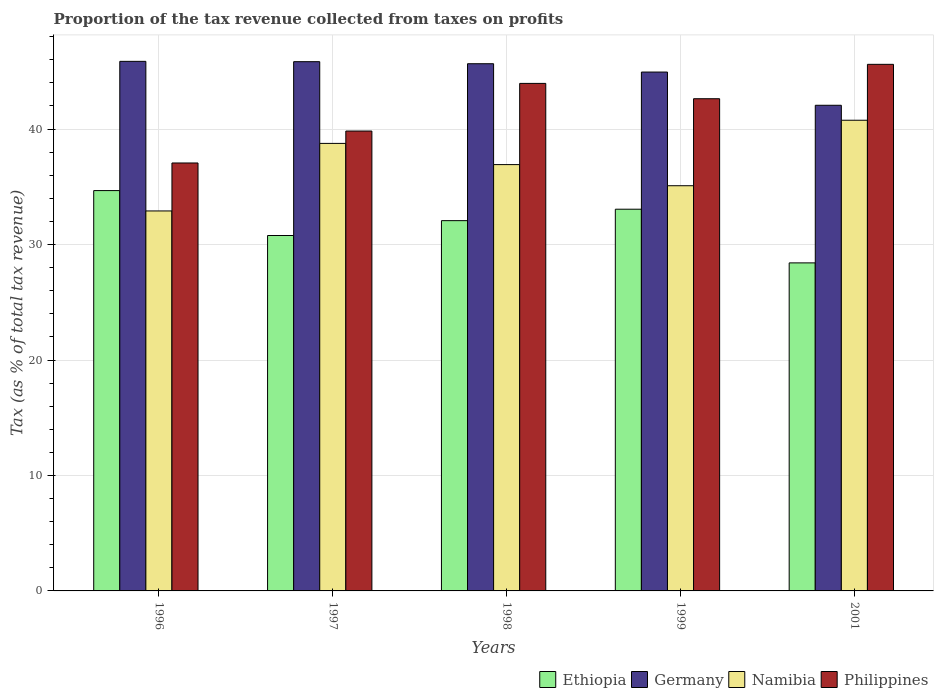How many different coloured bars are there?
Ensure brevity in your answer.  4. How many groups of bars are there?
Provide a succinct answer. 5. How many bars are there on the 4th tick from the left?
Provide a succinct answer. 4. How many bars are there on the 4th tick from the right?
Provide a succinct answer. 4. In how many cases, is the number of bars for a given year not equal to the number of legend labels?
Offer a terse response. 0. What is the proportion of the tax revenue collected in Namibia in 2001?
Keep it short and to the point. 40.77. Across all years, what is the maximum proportion of the tax revenue collected in Namibia?
Keep it short and to the point. 40.77. Across all years, what is the minimum proportion of the tax revenue collected in Ethiopia?
Provide a short and direct response. 28.41. What is the total proportion of the tax revenue collected in Ethiopia in the graph?
Provide a short and direct response. 159. What is the difference between the proportion of the tax revenue collected in Philippines in 1996 and that in 2001?
Make the answer very short. -8.54. What is the difference between the proportion of the tax revenue collected in Philippines in 1999 and the proportion of the tax revenue collected in Germany in 1996?
Give a very brief answer. -3.24. What is the average proportion of the tax revenue collected in Ethiopia per year?
Provide a short and direct response. 31.8. In the year 1998, what is the difference between the proportion of the tax revenue collected in Ethiopia and proportion of the tax revenue collected in Namibia?
Your answer should be very brief. -4.85. What is the ratio of the proportion of the tax revenue collected in Ethiopia in 1997 to that in 1998?
Keep it short and to the point. 0.96. Is the proportion of the tax revenue collected in Ethiopia in 1996 less than that in 1997?
Provide a short and direct response. No. Is the difference between the proportion of the tax revenue collected in Ethiopia in 1997 and 2001 greater than the difference between the proportion of the tax revenue collected in Namibia in 1997 and 2001?
Your answer should be compact. Yes. What is the difference between the highest and the second highest proportion of the tax revenue collected in Ethiopia?
Ensure brevity in your answer.  1.61. What is the difference between the highest and the lowest proportion of the tax revenue collected in Philippines?
Your answer should be very brief. 8.54. What does the 1st bar from the left in 1999 represents?
Ensure brevity in your answer.  Ethiopia. How many bars are there?
Provide a short and direct response. 20. How many years are there in the graph?
Provide a short and direct response. 5. What is the difference between two consecutive major ticks on the Y-axis?
Provide a succinct answer. 10. Where does the legend appear in the graph?
Make the answer very short. Bottom right. How many legend labels are there?
Offer a very short reply. 4. What is the title of the graph?
Keep it short and to the point. Proportion of the tax revenue collected from taxes on profits. What is the label or title of the X-axis?
Your answer should be compact. Years. What is the label or title of the Y-axis?
Ensure brevity in your answer.  Tax (as % of total tax revenue). What is the Tax (as % of total tax revenue) in Ethiopia in 1996?
Your response must be concise. 34.67. What is the Tax (as % of total tax revenue) of Germany in 1996?
Provide a short and direct response. 45.87. What is the Tax (as % of total tax revenue) in Namibia in 1996?
Offer a terse response. 32.91. What is the Tax (as % of total tax revenue) in Philippines in 1996?
Keep it short and to the point. 37.06. What is the Tax (as % of total tax revenue) in Ethiopia in 1997?
Provide a succinct answer. 30.78. What is the Tax (as % of total tax revenue) of Germany in 1997?
Provide a succinct answer. 45.84. What is the Tax (as % of total tax revenue) in Namibia in 1997?
Provide a succinct answer. 38.76. What is the Tax (as % of total tax revenue) of Philippines in 1997?
Your answer should be very brief. 39.83. What is the Tax (as % of total tax revenue) in Ethiopia in 1998?
Give a very brief answer. 32.07. What is the Tax (as % of total tax revenue) in Germany in 1998?
Provide a short and direct response. 45.66. What is the Tax (as % of total tax revenue) in Namibia in 1998?
Ensure brevity in your answer.  36.92. What is the Tax (as % of total tax revenue) of Philippines in 1998?
Give a very brief answer. 43.96. What is the Tax (as % of total tax revenue) in Ethiopia in 1999?
Keep it short and to the point. 33.06. What is the Tax (as % of total tax revenue) of Germany in 1999?
Your answer should be compact. 44.94. What is the Tax (as % of total tax revenue) of Namibia in 1999?
Give a very brief answer. 35.09. What is the Tax (as % of total tax revenue) in Philippines in 1999?
Offer a terse response. 42.63. What is the Tax (as % of total tax revenue) in Ethiopia in 2001?
Keep it short and to the point. 28.41. What is the Tax (as % of total tax revenue) in Germany in 2001?
Provide a succinct answer. 42.06. What is the Tax (as % of total tax revenue) of Namibia in 2001?
Your answer should be compact. 40.77. What is the Tax (as % of total tax revenue) in Philippines in 2001?
Offer a very short reply. 45.61. Across all years, what is the maximum Tax (as % of total tax revenue) of Ethiopia?
Provide a short and direct response. 34.67. Across all years, what is the maximum Tax (as % of total tax revenue) in Germany?
Provide a succinct answer. 45.87. Across all years, what is the maximum Tax (as % of total tax revenue) of Namibia?
Provide a succinct answer. 40.77. Across all years, what is the maximum Tax (as % of total tax revenue) of Philippines?
Your answer should be compact. 45.61. Across all years, what is the minimum Tax (as % of total tax revenue) in Ethiopia?
Offer a very short reply. 28.41. Across all years, what is the minimum Tax (as % of total tax revenue) of Germany?
Ensure brevity in your answer.  42.06. Across all years, what is the minimum Tax (as % of total tax revenue) of Namibia?
Make the answer very short. 32.91. Across all years, what is the minimum Tax (as % of total tax revenue) of Philippines?
Give a very brief answer. 37.06. What is the total Tax (as % of total tax revenue) of Ethiopia in the graph?
Make the answer very short. 159. What is the total Tax (as % of total tax revenue) of Germany in the graph?
Offer a terse response. 224.36. What is the total Tax (as % of total tax revenue) of Namibia in the graph?
Your answer should be compact. 184.45. What is the total Tax (as % of total tax revenue) in Philippines in the graph?
Keep it short and to the point. 209.09. What is the difference between the Tax (as % of total tax revenue) in Ethiopia in 1996 and that in 1997?
Give a very brief answer. 3.89. What is the difference between the Tax (as % of total tax revenue) of Germany in 1996 and that in 1997?
Provide a succinct answer. 0.03. What is the difference between the Tax (as % of total tax revenue) of Namibia in 1996 and that in 1997?
Offer a very short reply. -5.85. What is the difference between the Tax (as % of total tax revenue) of Philippines in 1996 and that in 1997?
Offer a terse response. -2.77. What is the difference between the Tax (as % of total tax revenue) in Ethiopia in 1996 and that in 1998?
Provide a short and direct response. 2.6. What is the difference between the Tax (as % of total tax revenue) of Germany in 1996 and that in 1998?
Your answer should be compact. 0.21. What is the difference between the Tax (as % of total tax revenue) of Namibia in 1996 and that in 1998?
Make the answer very short. -4.01. What is the difference between the Tax (as % of total tax revenue) in Philippines in 1996 and that in 1998?
Your answer should be compact. -6.89. What is the difference between the Tax (as % of total tax revenue) in Ethiopia in 1996 and that in 1999?
Make the answer very short. 1.61. What is the difference between the Tax (as % of total tax revenue) of Germany in 1996 and that in 1999?
Provide a short and direct response. 0.93. What is the difference between the Tax (as % of total tax revenue) of Namibia in 1996 and that in 1999?
Your answer should be very brief. -2.18. What is the difference between the Tax (as % of total tax revenue) in Philippines in 1996 and that in 1999?
Offer a terse response. -5.57. What is the difference between the Tax (as % of total tax revenue) in Ethiopia in 1996 and that in 2001?
Keep it short and to the point. 6.26. What is the difference between the Tax (as % of total tax revenue) in Germany in 1996 and that in 2001?
Ensure brevity in your answer.  3.8. What is the difference between the Tax (as % of total tax revenue) of Namibia in 1996 and that in 2001?
Make the answer very short. -7.86. What is the difference between the Tax (as % of total tax revenue) in Philippines in 1996 and that in 2001?
Keep it short and to the point. -8.54. What is the difference between the Tax (as % of total tax revenue) of Ethiopia in 1997 and that in 1998?
Offer a terse response. -1.29. What is the difference between the Tax (as % of total tax revenue) of Germany in 1997 and that in 1998?
Offer a very short reply. 0.18. What is the difference between the Tax (as % of total tax revenue) of Namibia in 1997 and that in 1998?
Offer a terse response. 1.84. What is the difference between the Tax (as % of total tax revenue) of Philippines in 1997 and that in 1998?
Ensure brevity in your answer.  -4.13. What is the difference between the Tax (as % of total tax revenue) in Ethiopia in 1997 and that in 1999?
Offer a very short reply. -2.28. What is the difference between the Tax (as % of total tax revenue) in Germany in 1997 and that in 1999?
Ensure brevity in your answer.  0.9. What is the difference between the Tax (as % of total tax revenue) of Namibia in 1997 and that in 1999?
Give a very brief answer. 3.67. What is the difference between the Tax (as % of total tax revenue) in Philippines in 1997 and that in 1999?
Offer a terse response. -2.8. What is the difference between the Tax (as % of total tax revenue) in Ethiopia in 1997 and that in 2001?
Offer a terse response. 2.37. What is the difference between the Tax (as % of total tax revenue) in Germany in 1997 and that in 2001?
Your answer should be compact. 3.78. What is the difference between the Tax (as % of total tax revenue) of Namibia in 1997 and that in 2001?
Give a very brief answer. -2.01. What is the difference between the Tax (as % of total tax revenue) of Philippines in 1997 and that in 2001?
Your response must be concise. -5.78. What is the difference between the Tax (as % of total tax revenue) in Ethiopia in 1998 and that in 1999?
Keep it short and to the point. -0.99. What is the difference between the Tax (as % of total tax revenue) in Germany in 1998 and that in 1999?
Provide a short and direct response. 0.72. What is the difference between the Tax (as % of total tax revenue) in Namibia in 1998 and that in 1999?
Offer a terse response. 1.83. What is the difference between the Tax (as % of total tax revenue) in Philippines in 1998 and that in 1999?
Make the answer very short. 1.33. What is the difference between the Tax (as % of total tax revenue) of Ethiopia in 1998 and that in 2001?
Keep it short and to the point. 3.66. What is the difference between the Tax (as % of total tax revenue) of Germany in 1998 and that in 2001?
Ensure brevity in your answer.  3.6. What is the difference between the Tax (as % of total tax revenue) in Namibia in 1998 and that in 2001?
Give a very brief answer. -3.84. What is the difference between the Tax (as % of total tax revenue) in Philippines in 1998 and that in 2001?
Offer a very short reply. -1.65. What is the difference between the Tax (as % of total tax revenue) in Ethiopia in 1999 and that in 2001?
Your answer should be compact. 4.65. What is the difference between the Tax (as % of total tax revenue) of Germany in 1999 and that in 2001?
Make the answer very short. 2.88. What is the difference between the Tax (as % of total tax revenue) of Namibia in 1999 and that in 2001?
Ensure brevity in your answer.  -5.67. What is the difference between the Tax (as % of total tax revenue) of Philippines in 1999 and that in 2001?
Offer a terse response. -2.98. What is the difference between the Tax (as % of total tax revenue) in Ethiopia in 1996 and the Tax (as % of total tax revenue) in Germany in 1997?
Provide a short and direct response. -11.16. What is the difference between the Tax (as % of total tax revenue) in Ethiopia in 1996 and the Tax (as % of total tax revenue) in Namibia in 1997?
Your answer should be very brief. -4.09. What is the difference between the Tax (as % of total tax revenue) in Ethiopia in 1996 and the Tax (as % of total tax revenue) in Philippines in 1997?
Offer a terse response. -5.16. What is the difference between the Tax (as % of total tax revenue) of Germany in 1996 and the Tax (as % of total tax revenue) of Namibia in 1997?
Provide a short and direct response. 7.11. What is the difference between the Tax (as % of total tax revenue) of Germany in 1996 and the Tax (as % of total tax revenue) of Philippines in 1997?
Ensure brevity in your answer.  6.04. What is the difference between the Tax (as % of total tax revenue) in Namibia in 1996 and the Tax (as % of total tax revenue) in Philippines in 1997?
Ensure brevity in your answer.  -6.92. What is the difference between the Tax (as % of total tax revenue) in Ethiopia in 1996 and the Tax (as % of total tax revenue) in Germany in 1998?
Provide a short and direct response. -10.99. What is the difference between the Tax (as % of total tax revenue) in Ethiopia in 1996 and the Tax (as % of total tax revenue) in Namibia in 1998?
Ensure brevity in your answer.  -2.25. What is the difference between the Tax (as % of total tax revenue) in Ethiopia in 1996 and the Tax (as % of total tax revenue) in Philippines in 1998?
Ensure brevity in your answer.  -9.28. What is the difference between the Tax (as % of total tax revenue) of Germany in 1996 and the Tax (as % of total tax revenue) of Namibia in 1998?
Offer a terse response. 8.94. What is the difference between the Tax (as % of total tax revenue) of Germany in 1996 and the Tax (as % of total tax revenue) of Philippines in 1998?
Keep it short and to the point. 1.91. What is the difference between the Tax (as % of total tax revenue) of Namibia in 1996 and the Tax (as % of total tax revenue) of Philippines in 1998?
Make the answer very short. -11.05. What is the difference between the Tax (as % of total tax revenue) in Ethiopia in 1996 and the Tax (as % of total tax revenue) in Germany in 1999?
Your answer should be very brief. -10.27. What is the difference between the Tax (as % of total tax revenue) of Ethiopia in 1996 and the Tax (as % of total tax revenue) of Namibia in 1999?
Your answer should be compact. -0.42. What is the difference between the Tax (as % of total tax revenue) in Ethiopia in 1996 and the Tax (as % of total tax revenue) in Philippines in 1999?
Offer a very short reply. -7.96. What is the difference between the Tax (as % of total tax revenue) of Germany in 1996 and the Tax (as % of total tax revenue) of Namibia in 1999?
Offer a very short reply. 10.77. What is the difference between the Tax (as % of total tax revenue) in Germany in 1996 and the Tax (as % of total tax revenue) in Philippines in 1999?
Ensure brevity in your answer.  3.24. What is the difference between the Tax (as % of total tax revenue) in Namibia in 1996 and the Tax (as % of total tax revenue) in Philippines in 1999?
Provide a short and direct response. -9.72. What is the difference between the Tax (as % of total tax revenue) in Ethiopia in 1996 and the Tax (as % of total tax revenue) in Germany in 2001?
Give a very brief answer. -7.39. What is the difference between the Tax (as % of total tax revenue) in Ethiopia in 1996 and the Tax (as % of total tax revenue) in Namibia in 2001?
Offer a terse response. -6.09. What is the difference between the Tax (as % of total tax revenue) of Ethiopia in 1996 and the Tax (as % of total tax revenue) of Philippines in 2001?
Offer a terse response. -10.93. What is the difference between the Tax (as % of total tax revenue) of Germany in 1996 and the Tax (as % of total tax revenue) of Namibia in 2001?
Offer a terse response. 5.1. What is the difference between the Tax (as % of total tax revenue) in Germany in 1996 and the Tax (as % of total tax revenue) in Philippines in 2001?
Ensure brevity in your answer.  0.26. What is the difference between the Tax (as % of total tax revenue) of Namibia in 1996 and the Tax (as % of total tax revenue) of Philippines in 2001?
Keep it short and to the point. -12.7. What is the difference between the Tax (as % of total tax revenue) in Ethiopia in 1997 and the Tax (as % of total tax revenue) in Germany in 1998?
Give a very brief answer. -14.88. What is the difference between the Tax (as % of total tax revenue) of Ethiopia in 1997 and the Tax (as % of total tax revenue) of Namibia in 1998?
Offer a terse response. -6.14. What is the difference between the Tax (as % of total tax revenue) in Ethiopia in 1997 and the Tax (as % of total tax revenue) in Philippines in 1998?
Your answer should be very brief. -13.17. What is the difference between the Tax (as % of total tax revenue) in Germany in 1997 and the Tax (as % of total tax revenue) in Namibia in 1998?
Keep it short and to the point. 8.91. What is the difference between the Tax (as % of total tax revenue) of Germany in 1997 and the Tax (as % of total tax revenue) of Philippines in 1998?
Your answer should be compact. 1.88. What is the difference between the Tax (as % of total tax revenue) in Namibia in 1997 and the Tax (as % of total tax revenue) in Philippines in 1998?
Keep it short and to the point. -5.2. What is the difference between the Tax (as % of total tax revenue) of Ethiopia in 1997 and the Tax (as % of total tax revenue) of Germany in 1999?
Your answer should be very brief. -14.16. What is the difference between the Tax (as % of total tax revenue) in Ethiopia in 1997 and the Tax (as % of total tax revenue) in Namibia in 1999?
Offer a terse response. -4.31. What is the difference between the Tax (as % of total tax revenue) of Ethiopia in 1997 and the Tax (as % of total tax revenue) of Philippines in 1999?
Offer a very short reply. -11.85. What is the difference between the Tax (as % of total tax revenue) in Germany in 1997 and the Tax (as % of total tax revenue) in Namibia in 1999?
Keep it short and to the point. 10.74. What is the difference between the Tax (as % of total tax revenue) of Germany in 1997 and the Tax (as % of total tax revenue) of Philippines in 1999?
Provide a succinct answer. 3.21. What is the difference between the Tax (as % of total tax revenue) in Namibia in 1997 and the Tax (as % of total tax revenue) in Philippines in 1999?
Keep it short and to the point. -3.87. What is the difference between the Tax (as % of total tax revenue) in Ethiopia in 1997 and the Tax (as % of total tax revenue) in Germany in 2001?
Provide a succinct answer. -11.28. What is the difference between the Tax (as % of total tax revenue) in Ethiopia in 1997 and the Tax (as % of total tax revenue) in Namibia in 2001?
Your answer should be compact. -9.98. What is the difference between the Tax (as % of total tax revenue) in Ethiopia in 1997 and the Tax (as % of total tax revenue) in Philippines in 2001?
Provide a succinct answer. -14.83. What is the difference between the Tax (as % of total tax revenue) of Germany in 1997 and the Tax (as % of total tax revenue) of Namibia in 2001?
Ensure brevity in your answer.  5.07. What is the difference between the Tax (as % of total tax revenue) of Germany in 1997 and the Tax (as % of total tax revenue) of Philippines in 2001?
Your answer should be very brief. 0.23. What is the difference between the Tax (as % of total tax revenue) in Namibia in 1997 and the Tax (as % of total tax revenue) in Philippines in 2001?
Ensure brevity in your answer.  -6.85. What is the difference between the Tax (as % of total tax revenue) of Ethiopia in 1998 and the Tax (as % of total tax revenue) of Germany in 1999?
Provide a short and direct response. -12.87. What is the difference between the Tax (as % of total tax revenue) of Ethiopia in 1998 and the Tax (as % of total tax revenue) of Namibia in 1999?
Your answer should be very brief. -3.02. What is the difference between the Tax (as % of total tax revenue) of Ethiopia in 1998 and the Tax (as % of total tax revenue) of Philippines in 1999?
Offer a terse response. -10.56. What is the difference between the Tax (as % of total tax revenue) in Germany in 1998 and the Tax (as % of total tax revenue) in Namibia in 1999?
Your response must be concise. 10.57. What is the difference between the Tax (as % of total tax revenue) of Germany in 1998 and the Tax (as % of total tax revenue) of Philippines in 1999?
Provide a succinct answer. 3.03. What is the difference between the Tax (as % of total tax revenue) of Namibia in 1998 and the Tax (as % of total tax revenue) of Philippines in 1999?
Offer a terse response. -5.71. What is the difference between the Tax (as % of total tax revenue) of Ethiopia in 1998 and the Tax (as % of total tax revenue) of Germany in 2001?
Your answer should be very brief. -9.99. What is the difference between the Tax (as % of total tax revenue) in Ethiopia in 1998 and the Tax (as % of total tax revenue) in Namibia in 2001?
Provide a succinct answer. -8.7. What is the difference between the Tax (as % of total tax revenue) of Ethiopia in 1998 and the Tax (as % of total tax revenue) of Philippines in 2001?
Your answer should be very brief. -13.54. What is the difference between the Tax (as % of total tax revenue) in Germany in 1998 and the Tax (as % of total tax revenue) in Namibia in 2001?
Give a very brief answer. 4.89. What is the difference between the Tax (as % of total tax revenue) of Germany in 1998 and the Tax (as % of total tax revenue) of Philippines in 2001?
Give a very brief answer. 0.05. What is the difference between the Tax (as % of total tax revenue) in Namibia in 1998 and the Tax (as % of total tax revenue) in Philippines in 2001?
Make the answer very short. -8.69. What is the difference between the Tax (as % of total tax revenue) in Ethiopia in 1999 and the Tax (as % of total tax revenue) in Germany in 2001?
Give a very brief answer. -9. What is the difference between the Tax (as % of total tax revenue) of Ethiopia in 1999 and the Tax (as % of total tax revenue) of Namibia in 2001?
Your answer should be compact. -7.71. What is the difference between the Tax (as % of total tax revenue) in Ethiopia in 1999 and the Tax (as % of total tax revenue) in Philippines in 2001?
Your answer should be compact. -12.55. What is the difference between the Tax (as % of total tax revenue) of Germany in 1999 and the Tax (as % of total tax revenue) of Namibia in 2001?
Offer a terse response. 4.17. What is the difference between the Tax (as % of total tax revenue) in Germany in 1999 and the Tax (as % of total tax revenue) in Philippines in 2001?
Your answer should be very brief. -0.67. What is the difference between the Tax (as % of total tax revenue) of Namibia in 1999 and the Tax (as % of total tax revenue) of Philippines in 2001?
Offer a terse response. -10.51. What is the average Tax (as % of total tax revenue) in Ethiopia per year?
Provide a succinct answer. 31.8. What is the average Tax (as % of total tax revenue) in Germany per year?
Your response must be concise. 44.87. What is the average Tax (as % of total tax revenue) in Namibia per year?
Offer a very short reply. 36.89. What is the average Tax (as % of total tax revenue) in Philippines per year?
Offer a very short reply. 41.82. In the year 1996, what is the difference between the Tax (as % of total tax revenue) of Ethiopia and Tax (as % of total tax revenue) of Germany?
Ensure brevity in your answer.  -11.19. In the year 1996, what is the difference between the Tax (as % of total tax revenue) of Ethiopia and Tax (as % of total tax revenue) of Namibia?
Keep it short and to the point. 1.76. In the year 1996, what is the difference between the Tax (as % of total tax revenue) of Ethiopia and Tax (as % of total tax revenue) of Philippines?
Give a very brief answer. -2.39. In the year 1996, what is the difference between the Tax (as % of total tax revenue) in Germany and Tax (as % of total tax revenue) in Namibia?
Your answer should be very brief. 12.96. In the year 1996, what is the difference between the Tax (as % of total tax revenue) in Germany and Tax (as % of total tax revenue) in Philippines?
Your answer should be very brief. 8.8. In the year 1996, what is the difference between the Tax (as % of total tax revenue) of Namibia and Tax (as % of total tax revenue) of Philippines?
Keep it short and to the point. -4.15. In the year 1997, what is the difference between the Tax (as % of total tax revenue) in Ethiopia and Tax (as % of total tax revenue) in Germany?
Offer a terse response. -15.05. In the year 1997, what is the difference between the Tax (as % of total tax revenue) in Ethiopia and Tax (as % of total tax revenue) in Namibia?
Offer a terse response. -7.98. In the year 1997, what is the difference between the Tax (as % of total tax revenue) in Ethiopia and Tax (as % of total tax revenue) in Philippines?
Offer a terse response. -9.05. In the year 1997, what is the difference between the Tax (as % of total tax revenue) in Germany and Tax (as % of total tax revenue) in Namibia?
Make the answer very short. 7.08. In the year 1997, what is the difference between the Tax (as % of total tax revenue) in Germany and Tax (as % of total tax revenue) in Philippines?
Your response must be concise. 6.01. In the year 1997, what is the difference between the Tax (as % of total tax revenue) of Namibia and Tax (as % of total tax revenue) of Philippines?
Ensure brevity in your answer.  -1.07. In the year 1998, what is the difference between the Tax (as % of total tax revenue) in Ethiopia and Tax (as % of total tax revenue) in Germany?
Your answer should be compact. -13.59. In the year 1998, what is the difference between the Tax (as % of total tax revenue) of Ethiopia and Tax (as % of total tax revenue) of Namibia?
Your response must be concise. -4.85. In the year 1998, what is the difference between the Tax (as % of total tax revenue) of Ethiopia and Tax (as % of total tax revenue) of Philippines?
Your answer should be compact. -11.89. In the year 1998, what is the difference between the Tax (as % of total tax revenue) in Germany and Tax (as % of total tax revenue) in Namibia?
Keep it short and to the point. 8.74. In the year 1998, what is the difference between the Tax (as % of total tax revenue) in Germany and Tax (as % of total tax revenue) in Philippines?
Offer a very short reply. 1.7. In the year 1998, what is the difference between the Tax (as % of total tax revenue) of Namibia and Tax (as % of total tax revenue) of Philippines?
Your answer should be compact. -7.03. In the year 1999, what is the difference between the Tax (as % of total tax revenue) in Ethiopia and Tax (as % of total tax revenue) in Germany?
Offer a terse response. -11.88. In the year 1999, what is the difference between the Tax (as % of total tax revenue) in Ethiopia and Tax (as % of total tax revenue) in Namibia?
Your answer should be compact. -2.03. In the year 1999, what is the difference between the Tax (as % of total tax revenue) of Ethiopia and Tax (as % of total tax revenue) of Philippines?
Offer a terse response. -9.57. In the year 1999, what is the difference between the Tax (as % of total tax revenue) in Germany and Tax (as % of total tax revenue) in Namibia?
Ensure brevity in your answer.  9.84. In the year 1999, what is the difference between the Tax (as % of total tax revenue) in Germany and Tax (as % of total tax revenue) in Philippines?
Make the answer very short. 2.31. In the year 1999, what is the difference between the Tax (as % of total tax revenue) of Namibia and Tax (as % of total tax revenue) of Philippines?
Keep it short and to the point. -7.53. In the year 2001, what is the difference between the Tax (as % of total tax revenue) of Ethiopia and Tax (as % of total tax revenue) of Germany?
Your answer should be compact. -13.65. In the year 2001, what is the difference between the Tax (as % of total tax revenue) in Ethiopia and Tax (as % of total tax revenue) in Namibia?
Your answer should be compact. -12.35. In the year 2001, what is the difference between the Tax (as % of total tax revenue) in Ethiopia and Tax (as % of total tax revenue) in Philippines?
Keep it short and to the point. -17.2. In the year 2001, what is the difference between the Tax (as % of total tax revenue) in Germany and Tax (as % of total tax revenue) in Namibia?
Make the answer very short. 1.3. In the year 2001, what is the difference between the Tax (as % of total tax revenue) in Germany and Tax (as % of total tax revenue) in Philippines?
Offer a very short reply. -3.55. In the year 2001, what is the difference between the Tax (as % of total tax revenue) of Namibia and Tax (as % of total tax revenue) of Philippines?
Give a very brief answer. -4.84. What is the ratio of the Tax (as % of total tax revenue) of Ethiopia in 1996 to that in 1997?
Your answer should be compact. 1.13. What is the ratio of the Tax (as % of total tax revenue) of Germany in 1996 to that in 1997?
Make the answer very short. 1. What is the ratio of the Tax (as % of total tax revenue) in Namibia in 1996 to that in 1997?
Give a very brief answer. 0.85. What is the ratio of the Tax (as % of total tax revenue) in Philippines in 1996 to that in 1997?
Ensure brevity in your answer.  0.93. What is the ratio of the Tax (as % of total tax revenue) in Ethiopia in 1996 to that in 1998?
Keep it short and to the point. 1.08. What is the ratio of the Tax (as % of total tax revenue) in Germany in 1996 to that in 1998?
Your answer should be very brief. 1. What is the ratio of the Tax (as % of total tax revenue) of Namibia in 1996 to that in 1998?
Your response must be concise. 0.89. What is the ratio of the Tax (as % of total tax revenue) of Philippines in 1996 to that in 1998?
Provide a short and direct response. 0.84. What is the ratio of the Tax (as % of total tax revenue) of Ethiopia in 1996 to that in 1999?
Provide a short and direct response. 1.05. What is the ratio of the Tax (as % of total tax revenue) of Germany in 1996 to that in 1999?
Keep it short and to the point. 1.02. What is the ratio of the Tax (as % of total tax revenue) of Namibia in 1996 to that in 1999?
Give a very brief answer. 0.94. What is the ratio of the Tax (as % of total tax revenue) of Philippines in 1996 to that in 1999?
Your answer should be compact. 0.87. What is the ratio of the Tax (as % of total tax revenue) in Ethiopia in 1996 to that in 2001?
Your answer should be very brief. 1.22. What is the ratio of the Tax (as % of total tax revenue) of Germany in 1996 to that in 2001?
Your answer should be compact. 1.09. What is the ratio of the Tax (as % of total tax revenue) in Namibia in 1996 to that in 2001?
Your answer should be very brief. 0.81. What is the ratio of the Tax (as % of total tax revenue) of Philippines in 1996 to that in 2001?
Ensure brevity in your answer.  0.81. What is the ratio of the Tax (as % of total tax revenue) of Ethiopia in 1997 to that in 1998?
Your answer should be compact. 0.96. What is the ratio of the Tax (as % of total tax revenue) in Germany in 1997 to that in 1998?
Ensure brevity in your answer.  1. What is the ratio of the Tax (as % of total tax revenue) in Namibia in 1997 to that in 1998?
Make the answer very short. 1.05. What is the ratio of the Tax (as % of total tax revenue) in Philippines in 1997 to that in 1998?
Provide a short and direct response. 0.91. What is the ratio of the Tax (as % of total tax revenue) of Ethiopia in 1997 to that in 1999?
Keep it short and to the point. 0.93. What is the ratio of the Tax (as % of total tax revenue) in Namibia in 1997 to that in 1999?
Give a very brief answer. 1.1. What is the ratio of the Tax (as % of total tax revenue) in Philippines in 1997 to that in 1999?
Keep it short and to the point. 0.93. What is the ratio of the Tax (as % of total tax revenue) of Ethiopia in 1997 to that in 2001?
Give a very brief answer. 1.08. What is the ratio of the Tax (as % of total tax revenue) in Germany in 1997 to that in 2001?
Ensure brevity in your answer.  1.09. What is the ratio of the Tax (as % of total tax revenue) of Namibia in 1997 to that in 2001?
Keep it short and to the point. 0.95. What is the ratio of the Tax (as % of total tax revenue) in Philippines in 1997 to that in 2001?
Keep it short and to the point. 0.87. What is the ratio of the Tax (as % of total tax revenue) in Ethiopia in 1998 to that in 1999?
Your answer should be very brief. 0.97. What is the ratio of the Tax (as % of total tax revenue) of Germany in 1998 to that in 1999?
Ensure brevity in your answer.  1.02. What is the ratio of the Tax (as % of total tax revenue) in Namibia in 1998 to that in 1999?
Make the answer very short. 1.05. What is the ratio of the Tax (as % of total tax revenue) of Philippines in 1998 to that in 1999?
Your response must be concise. 1.03. What is the ratio of the Tax (as % of total tax revenue) in Ethiopia in 1998 to that in 2001?
Keep it short and to the point. 1.13. What is the ratio of the Tax (as % of total tax revenue) in Germany in 1998 to that in 2001?
Your answer should be very brief. 1.09. What is the ratio of the Tax (as % of total tax revenue) of Namibia in 1998 to that in 2001?
Offer a very short reply. 0.91. What is the ratio of the Tax (as % of total tax revenue) of Philippines in 1998 to that in 2001?
Keep it short and to the point. 0.96. What is the ratio of the Tax (as % of total tax revenue) of Ethiopia in 1999 to that in 2001?
Ensure brevity in your answer.  1.16. What is the ratio of the Tax (as % of total tax revenue) of Germany in 1999 to that in 2001?
Offer a very short reply. 1.07. What is the ratio of the Tax (as % of total tax revenue) in Namibia in 1999 to that in 2001?
Ensure brevity in your answer.  0.86. What is the ratio of the Tax (as % of total tax revenue) of Philippines in 1999 to that in 2001?
Offer a very short reply. 0.93. What is the difference between the highest and the second highest Tax (as % of total tax revenue) in Ethiopia?
Offer a terse response. 1.61. What is the difference between the highest and the second highest Tax (as % of total tax revenue) of Germany?
Give a very brief answer. 0.03. What is the difference between the highest and the second highest Tax (as % of total tax revenue) of Namibia?
Keep it short and to the point. 2.01. What is the difference between the highest and the second highest Tax (as % of total tax revenue) of Philippines?
Your answer should be very brief. 1.65. What is the difference between the highest and the lowest Tax (as % of total tax revenue) in Ethiopia?
Your answer should be compact. 6.26. What is the difference between the highest and the lowest Tax (as % of total tax revenue) in Germany?
Your response must be concise. 3.8. What is the difference between the highest and the lowest Tax (as % of total tax revenue) in Namibia?
Keep it short and to the point. 7.86. What is the difference between the highest and the lowest Tax (as % of total tax revenue) of Philippines?
Make the answer very short. 8.54. 